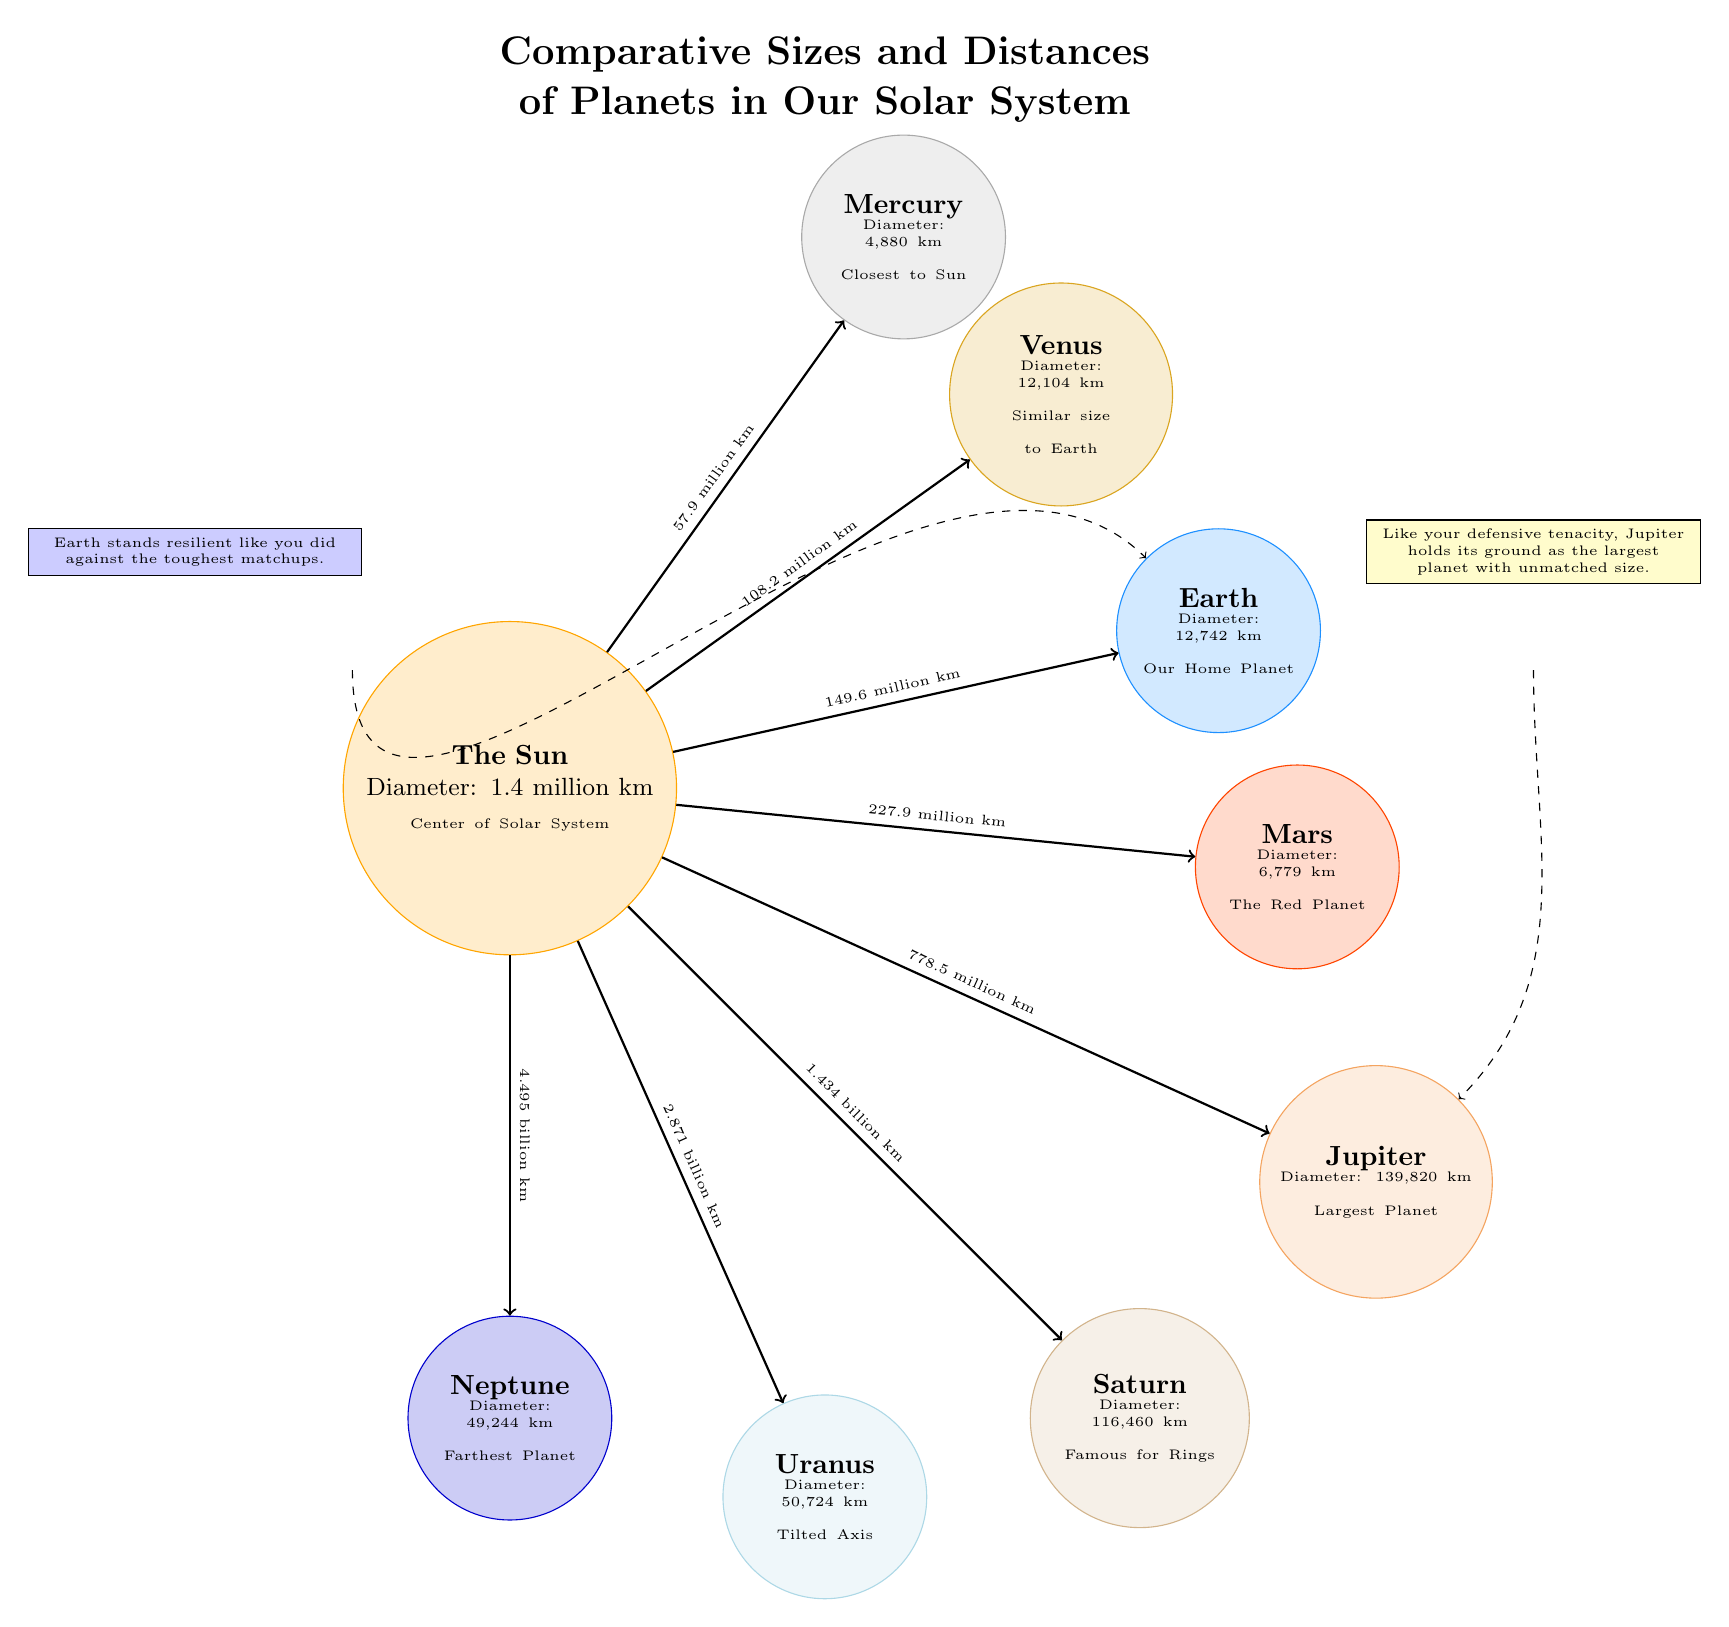What is the diameter of Jupiter? The diagram shows that Jupiter has a diameter listed as "139,820 km." This information is directly stated within the circle representing Jupiter.
Answer: 139,820 km How far is Mars from the Sun? From the diagram, a line is drawn from the Sun to Mars with a label indicating the distance, which is "227.9 million km." This is directly mentioned in the diagram.
Answer: 227.9 million km Which planet has a diameter closest to Earth? The diagram shows that Earth has a diameter of "12,742 km" and Venus has a diameter of "12,104 km," making Venus the closest in size to Earth. Comparing the two, Venus is clearly noted as similar in size to Earth.
Answer: Venus Which planet is the farthest from the Sun? The diagram contains a label indicating Neptune as the "Farthest Planet," and the distance is noted as "4.495 billion km." This context makes it clear that Neptune is the farthest planet from the Sun.
Answer: Neptune What is the diameter of Saturn compared to Uranus? The diagram lists Saturn's diameter as "116,460 km" and Uranus' diameter as "50,724 km." By comparison, Saturn is significantly larger, having more than double the diameter of Uranus.
Answer: Saturn How many planets are shown in this diagram? The diagram displays 8 distinct planets, including the Sun. Each planet is represented with a labeled circle. Counting these gives a total of 8.
Answer: 8 Which planet is known for its rings? The diagram explicitly states that Saturn is "Famous for Rings" within its description. This makes it clear that Saturn is recognized for this characteristic.
Answer: Saturn What does the label adjacent to Jupiter imply? The diagram states, "Like your defensive tenacity, Jupiter holds its ground as the largest planet with unmatched size." This suggests that Jupiter's size is unparalleled among the planets shown, symbolizing strength and resilience.
Answer: Unmatched size What is the diameter of Mercury? The diagram indicates that Mercury's diameter is "4,880 km", which is presented inside the circle representing Mercury.
Answer: 4,880 km 